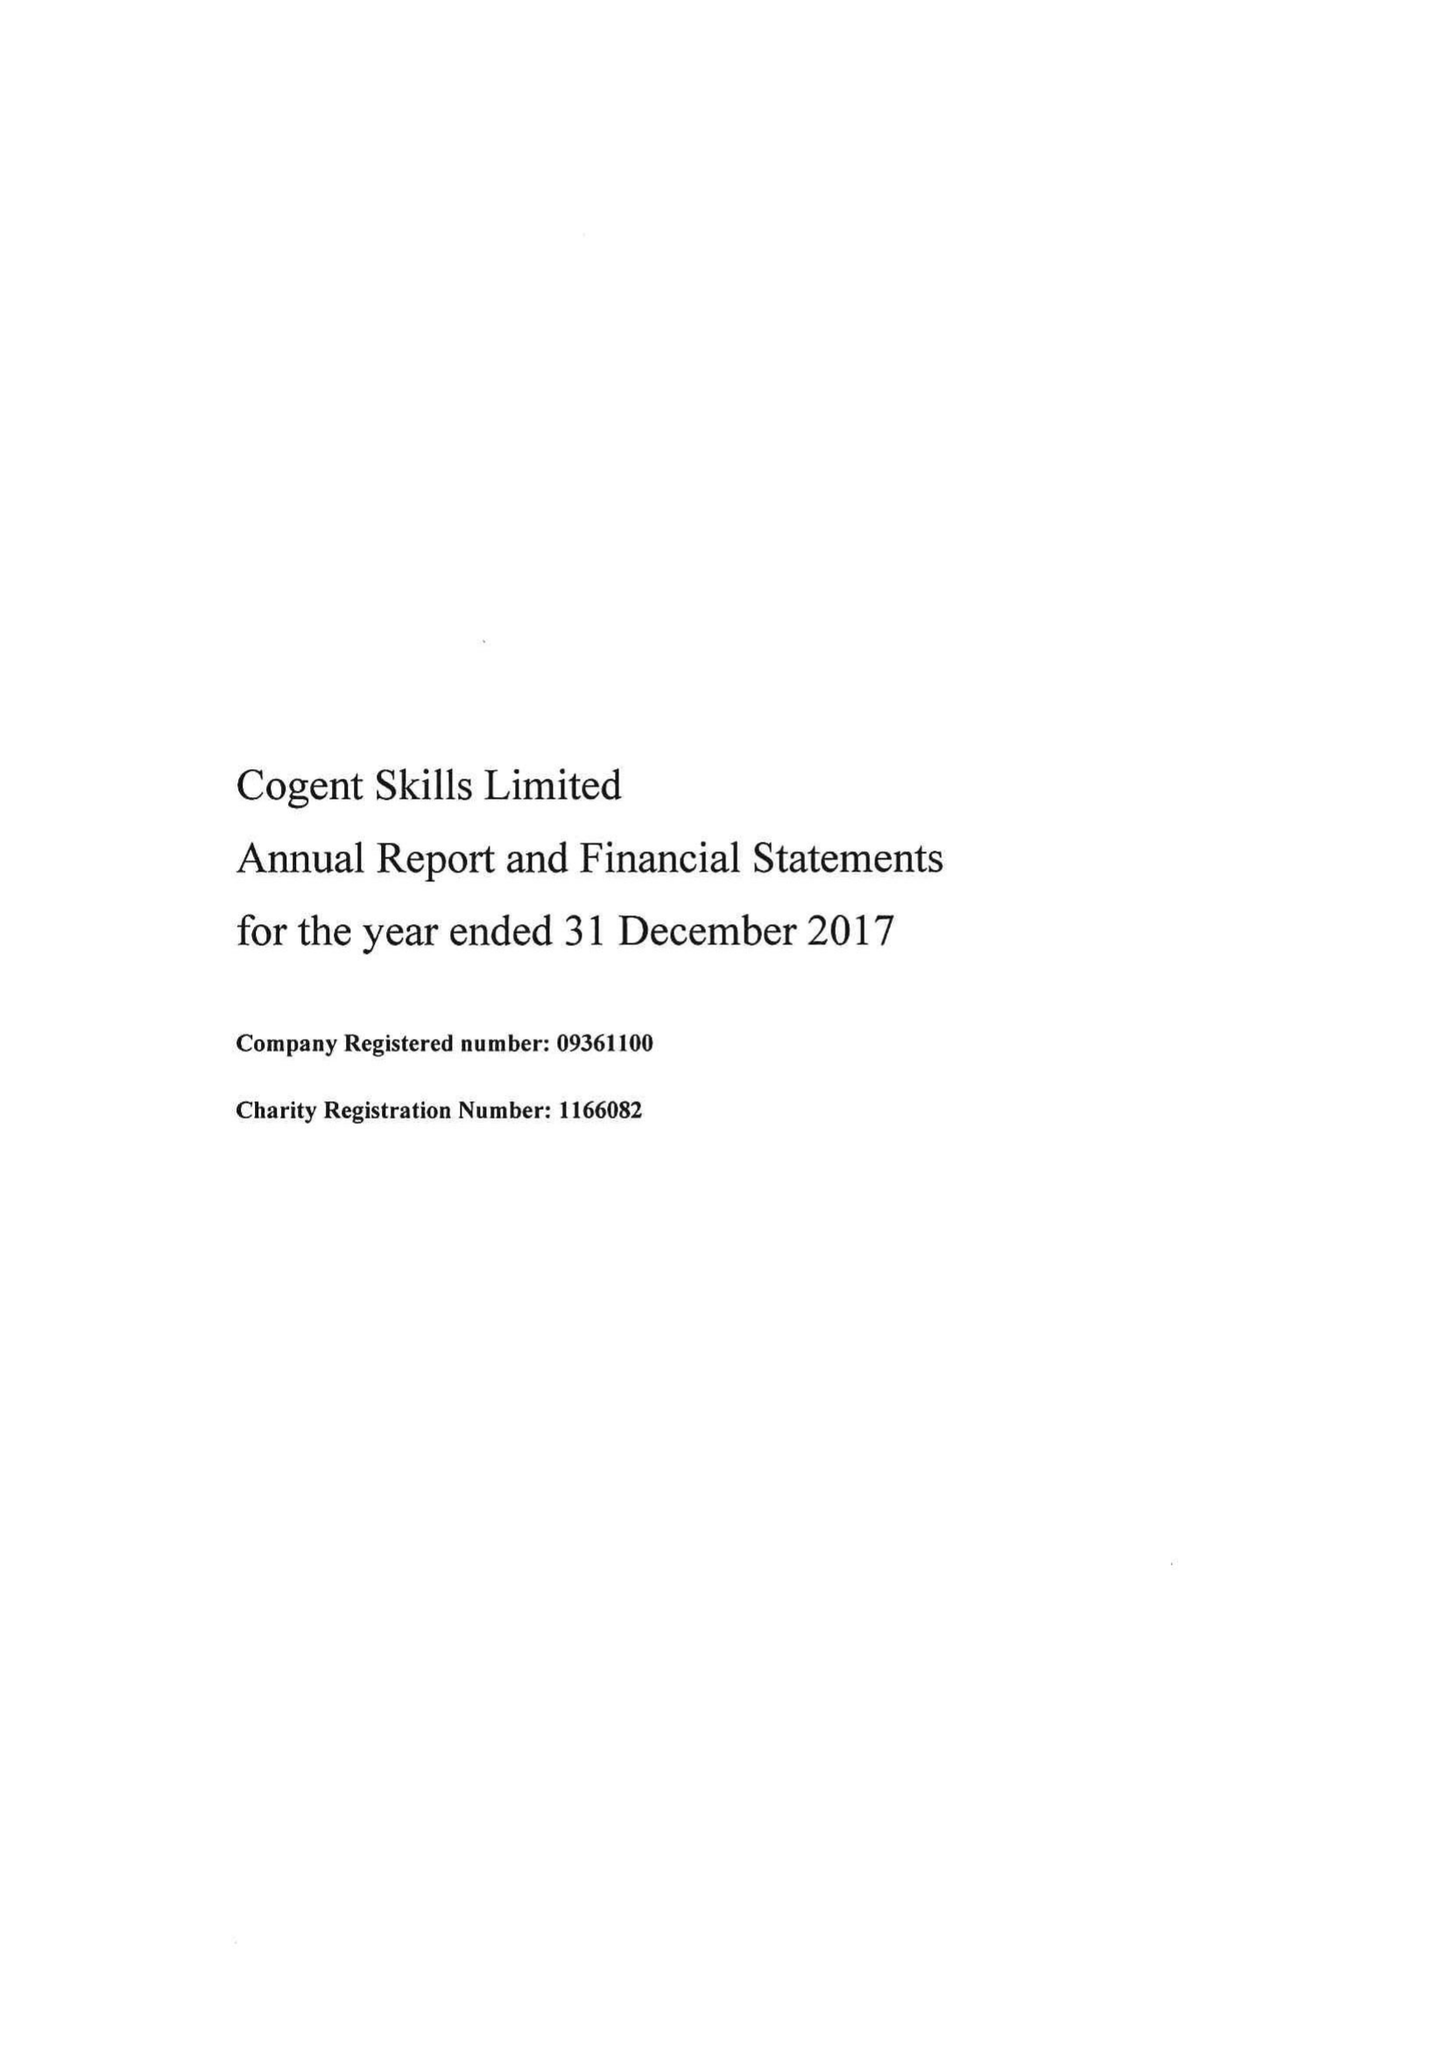What is the value for the address__postcode?
Answer the question using a single word or phrase. WA1 1 GG 